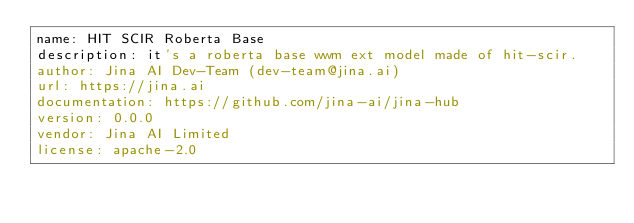Convert code to text. <code><loc_0><loc_0><loc_500><loc_500><_YAML_>name: HIT SCIR Roberta Base
description: it's a roberta base wwm ext model made of hit-scir.
author: Jina AI Dev-Team (dev-team@jina.ai)
url: https://jina.ai
documentation: https://github.com/jina-ai/jina-hub
version: 0.0.0
vendor: Jina AI Limited
license: apache-2.0</code> 